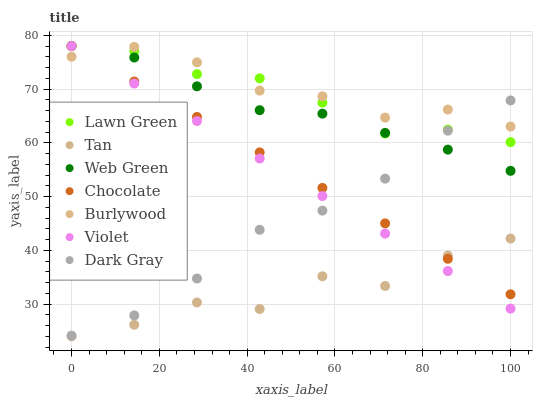Does Tan have the minimum area under the curve?
Answer yes or no. Yes. Does Burlywood have the maximum area under the curve?
Answer yes or no. Yes. Does Web Green have the minimum area under the curve?
Answer yes or no. No. Does Web Green have the maximum area under the curve?
Answer yes or no. No. Is Violet the smoothest?
Answer yes or no. Yes. Is Tan the roughest?
Answer yes or no. Yes. Is Burlywood the smoothest?
Answer yes or no. No. Is Burlywood the roughest?
Answer yes or no. No. Does Tan have the lowest value?
Answer yes or no. Yes. Does Web Green have the lowest value?
Answer yes or no. No. Does Violet have the highest value?
Answer yes or no. Yes. Does Burlywood have the highest value?
Answer yes or no. No. Is Tan less than Burlywood?
Answer yes or no. Yes. Is Dark Gray greater than Tan?
Answer yes or no. Yes. Does Dark Gray intersect Lawn Green?
Answer yes or no. Yes. Is Dark Gray less than Lawn Green?
Answer yes or no. No. Is Dark Gray greater than Lawn Green?
Answer yes or no. No. Does Tan intersect Burlywood?
Answer yes or no. No. 